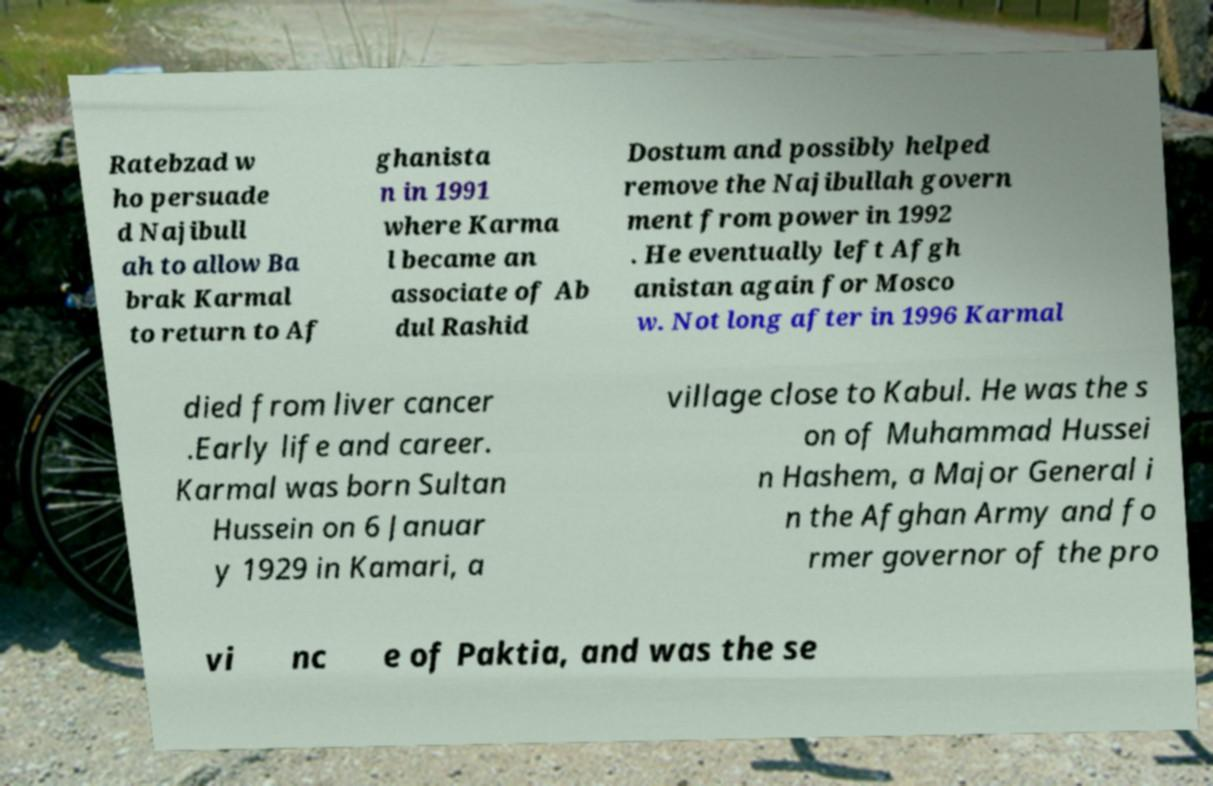There's text embedded in this image that I need extracted. Can you transcribe it verbatim? Ratebzad w ho persuade d Najibull ah to allow Ba brak Karmal to return to Af ghanista n in 1991 where Karma l became an associate of Ab dul Rashid Dostum and possibly helped remove the Najibullah govern ment from power in 1992 . He eventually left Afgh anistan again for Mosco w. Not long after in 1996 Karmal died from liver cancer .Early life and career. Karmal was born Sultan Hussein on 6 Januar y 1929 in Kamari, a village close to Kabul. He was the s on of Muhammad Hussei n Hashem, a Major General i n the Afghan Army and fo rmer governor of the pro vi nc e of Paktia, and was the se 